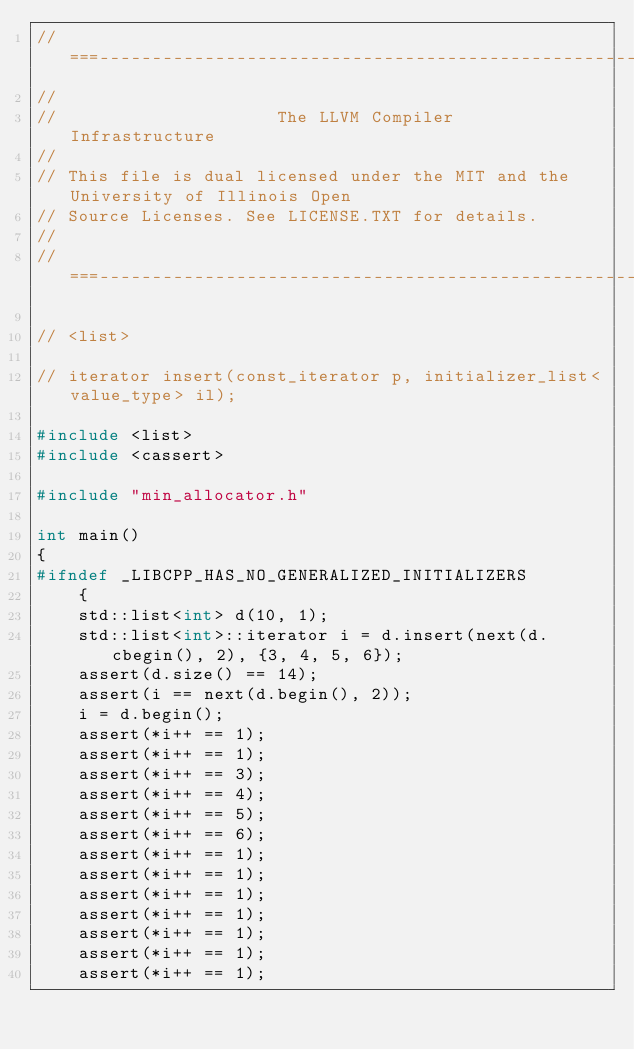Convert code to text. <code><loc_0><loc_0><loc_500><loc_500><_C++_>//===----------------------------------------------------------------------===//
//
//                     The LLVM Compiler Infrastructure
//
// This file is dual licensed under the MIT and the University of Illinois Open
// Source Licenses. See LICENSE.TXT for details.
//
//===----------------------------------------------------------------------===//

// <list>

// iterator insert(const_iterator p, initializer_list<value_type> il);

#include <list>
#include <cassert>

#include "min_allocator.h"

int main()
{
#ifndef _LIBCPP_HAS_NO_GENERALIZED_INITIALIZERS
    {
    std::list<int> d(10, 1);
    std::list<int>::iterator i = d.insert(next(d.cbegin(), 2), {3, 4, 5, 6});
    assert(d.size() == 14);
    assert(i == next(d.begin(), 2));
    i = d.begin();
    assert(*i++ == 1);
    assert(*i++ == 1);
    assert(*i++ == 3);
    assert(*i++ == 4);
    assert(*i++ == 5);
    assert(*i++ == 6);
    assert(*i++ == 1);
    assert(*i++ == 1);
    assert(*i++ == 1);
    assert(*i++ == 1);
    assert(*i++ == 1);
    assert(*i++ == 1);
    assert(*i++ == 1);</code> 